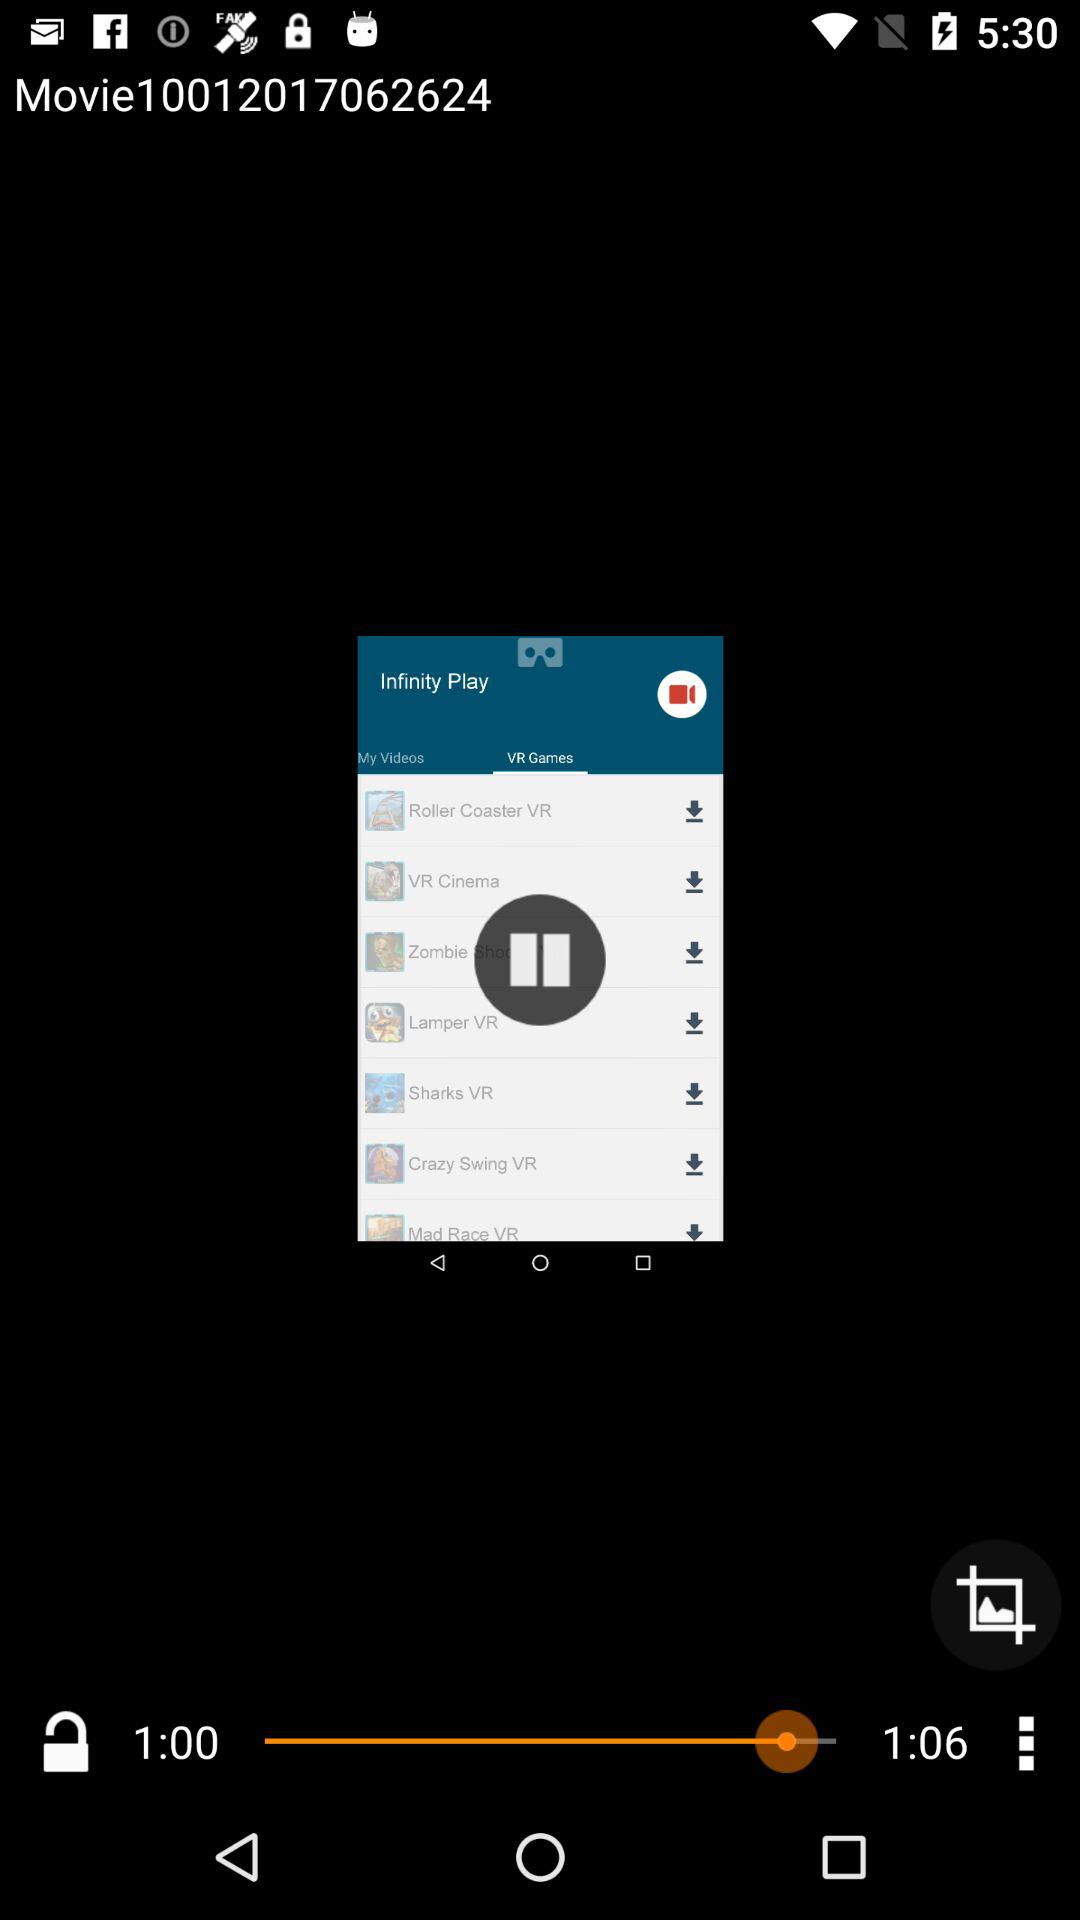How many more seconds is the second time stamp than the first?
Answer the question using a single word or phrase. 6 